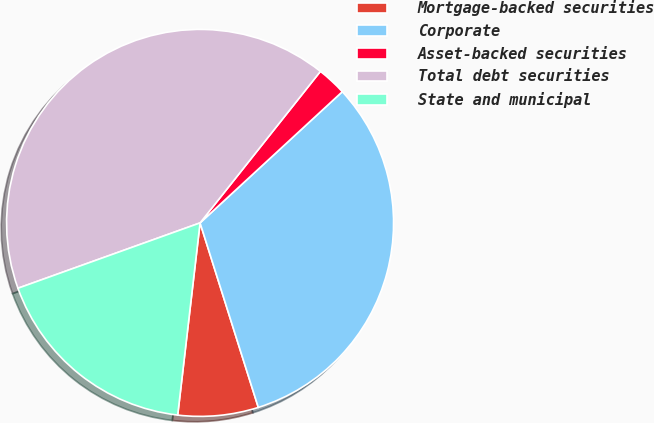Convert chart. <chart><loc_0><loc_0><loc_500><loc_500><pie_chart><fcel>Mortgage-backed securities<fcel>Corporate<fcel>Asset-backed securities<fcel>Total debt securities<fcel>State and municipal<nl><fcel>6.71%<fcel>31.99%<fcel>2.46%<fcel>41.16%<fcel>17.67%<nl></chart> 